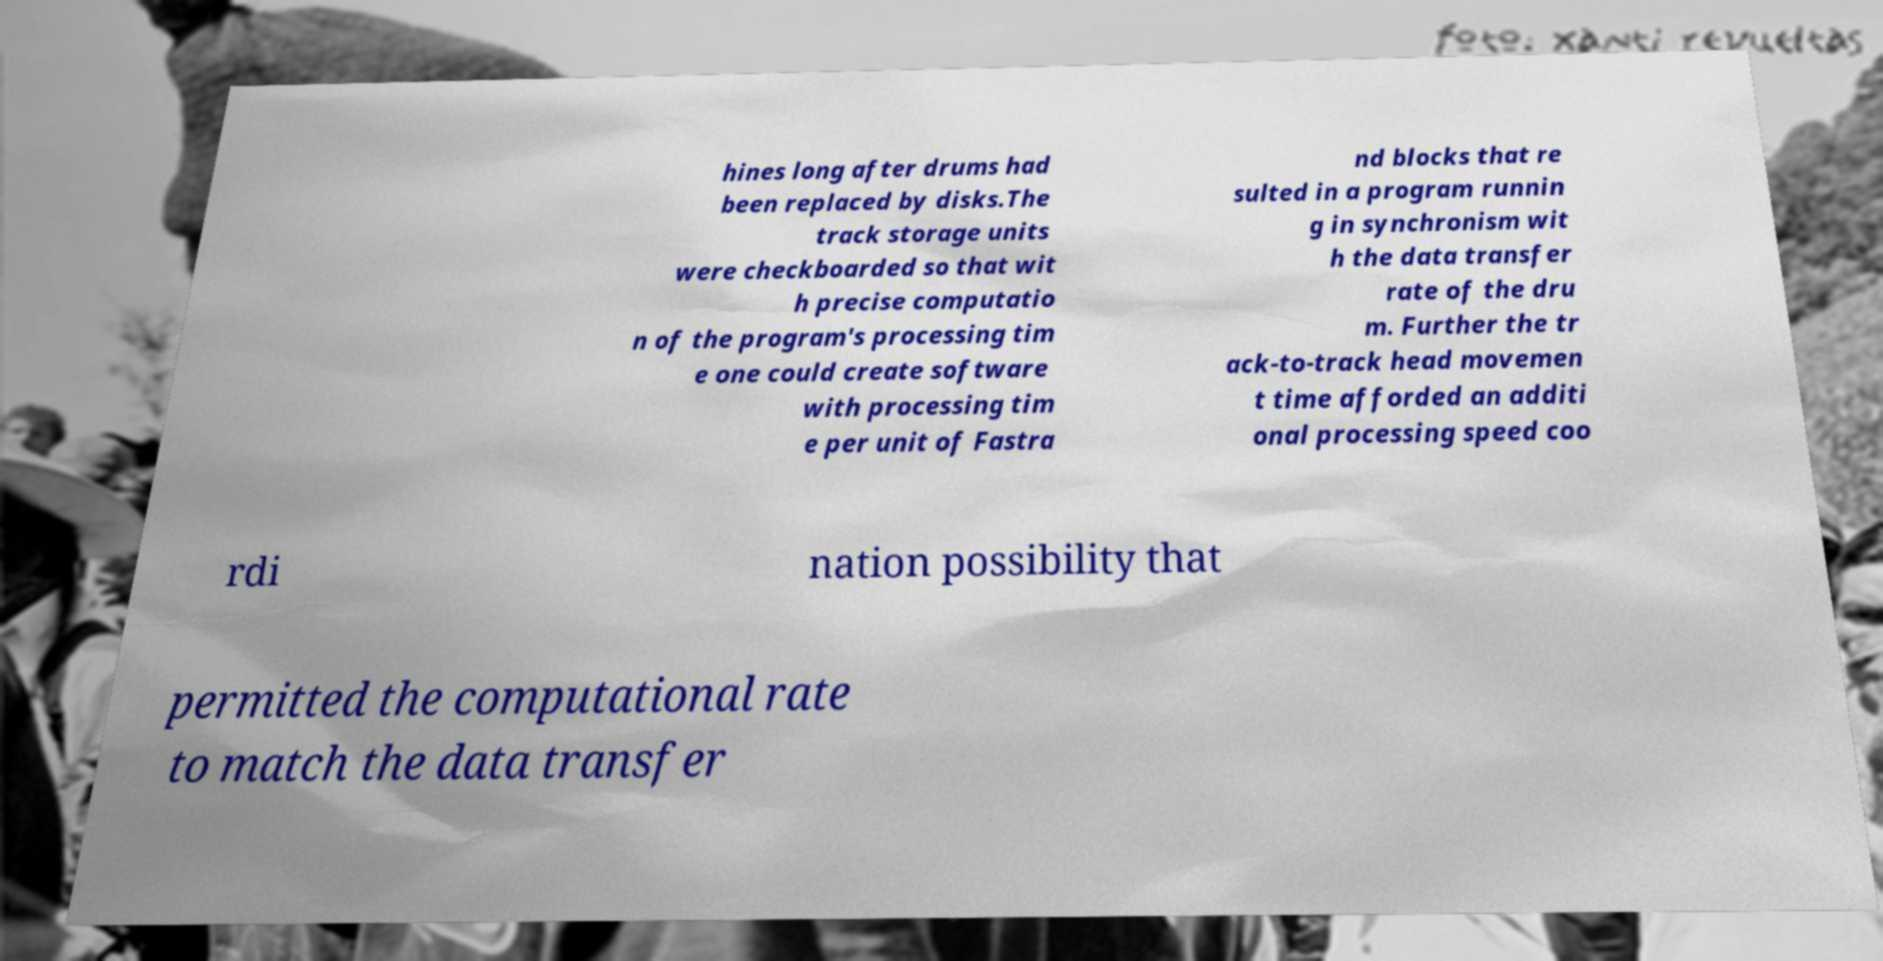Could you assist in decoding the text presented in this image and type it out clearly? hines long after drums had been replaced by disks.The track storage units were checkboarded so that wit h precise computatio n of the program's processing tim e one could create software with processing tim e per unit of Fastra nd blocks that re sulted in a program runnin g in synchronism wit h the data transfer rate of the dru m. Further the tr ack-to-track head movemen t time afforded an additi onal processing speed coo rdi nation possibility that permitted the computational rate to match the data transfer 